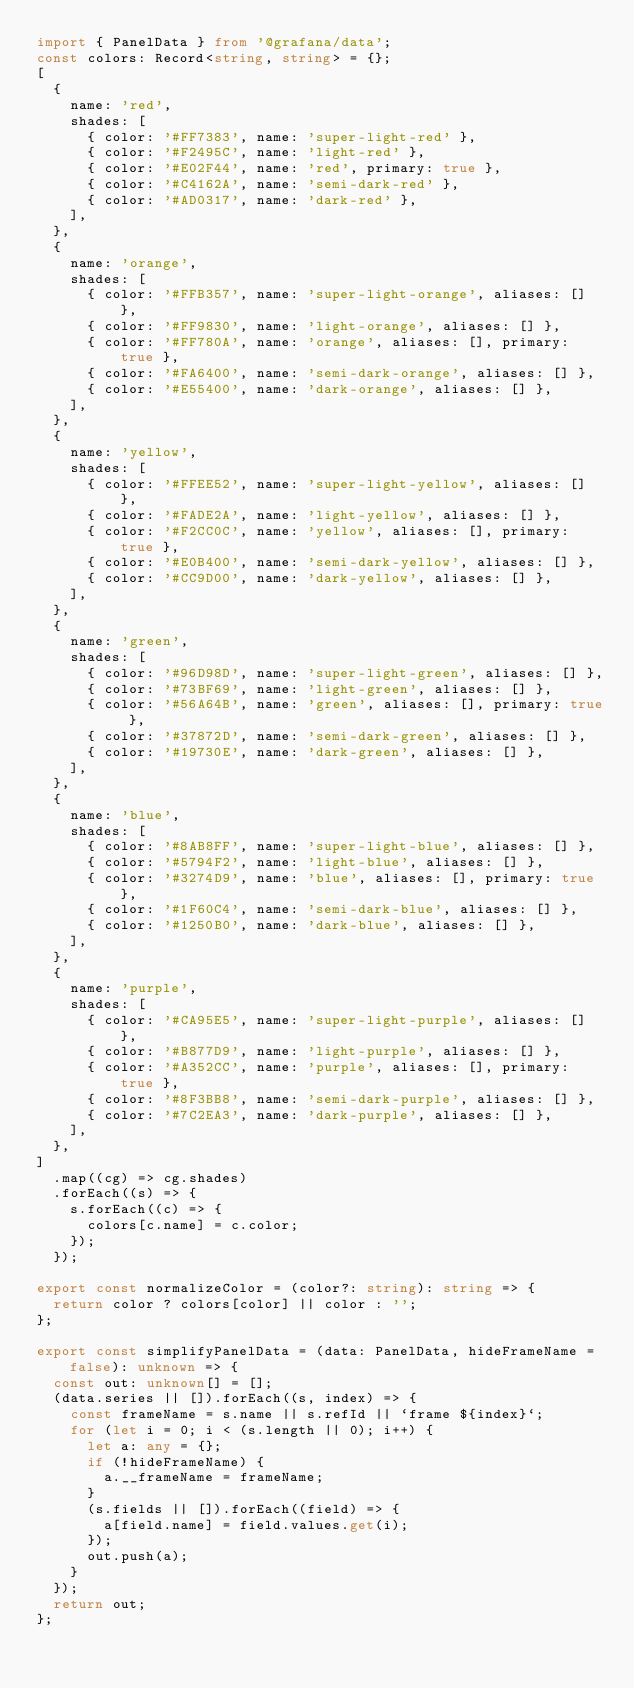Convert code to text. <code><loc_0><loc_0><loc_500><loc_500><_TypeScript_>import { PanelData } from '@grafana/data';
const colors: Record<string, string> = {};
[
  {
    name: 'red',
    shades: [
      { color: '#FF7383', name: 'super-light-red' },
      { color: '#F2495C', name: 'light-red' },
      { color: '#E02F44', name: 'red', primary: true },
      { color: '#C4162A', name: 'semi-dark-red' },
      { color: '#AD0317', name: 'dark-red' },
    ],
  },
  {
    name: 'orange',
    shades: [
      { color: '#FFB357', name: 'super-light-orange', aliases: [] },
      { color: '#FF9830', name: 'light-orange', aliases: [] },
      { color: '#FF780A', name: 'orange', aliases: [], primary: true },
      { color: '#FA6400', name: 'semi-dark-orange', aliases: [] },
      { color: '#E55400', name: 'dark-orange', aliases: [] },
    ],
  },
  {
    name: 'yellow',
    shades: [
      { color: '#FFEE52', name: 'super-light-yellow', aliases: [] },
      { color: '#FADE2A', name: 'light-yellow', aliases: [] },
      { color: '#F2CC0C', name: 'yellow', aliases: [], primary: true },
      { color: '#E0B400', name: 'semi-dark-yellow', aliases: [] },
      { color: '#CC9D00', name: 'dark-yellow', aliases: [] },
    ],
  },
  {
    name: 'green',
    shades: [
      { color: '#96D98D', name: 'super-light-green', aliases: [] },
      { color: '#73BF69', name: 'light-green', aliases: [] },
      { color: '#56A64B', name: 'green', aliases: [], primary: true },
      { color: '#37872D', name: 'semi-dark-green', aliases: [] },
      { color: '#19730E', name: 'dark-green', aliases: [] },
    ],
  },
  {
    name: 'blue',
    shades: [
      { color: '#8AB8FF', name: 'super-light-blue', aliases: [] },
      { color: '#5794F2', name: 'light-blue', aliases: [] },
      { color: '#3274D9', name: 'blue', aliases: [], primary: true },
      { color: '#1F60C4', name: 'semi-dark-blue', aliases: [] },
      { color: '#1250B0', name: 'dark-blue', aliases: [] },
    ],
  },
  {
    name: 'purple',
    shades: [
      { color: '#CA95E5', name: 'super-light-purple', aliases: [] },
      { color: '#B877D9', name: 'light-purple', aliases: [] },
      { color: '#A352CC', name: 'purple', aliases: [], primary: true },
      { color: '#8F3BB8', name: 'semi-dark-purple', aliases: [] },
      { color: '#7C2EA3', name: 'dark-purple', aliases: [] },
    ],
  },
]
  .map((cg) => cg.shades)
  .forEach((s) => {
    s.forEach((c) => {
      colors[c.name] = c.color;
    });
  });

export const normalizeColor = (color?: string): string => {
  return color ? colors[color] || color : '';
};

export const simplifyPanelData = (data: PanelData, hideFrameName = false): unknown => {
  const out: unknown[] = [];
  (data.series || []).forEach((s, index) => {
    const frameName = s.name || s.refId || `frame ${index}`;
    for (let i = 0; i < (s.length || 0); i++) {
      let a: any = {};
      if (!hideFrameName) {
        a.__frameName = frameName;
      }
      (s.fields || []).forEach((field) => {
        a[field.name] = field.values.get(i);
      });
      out.push(a);
    }
  });
  return out;
};
</code> 